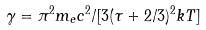Convert formula to latex. <formula><loc_0><loc_0><loc_500><loc_500>\gamma = \pi ^ { 2 } m _ { e } c ^ { 2 } / [ 3 ( \tau + 2 / 3 ) ^ { 2 } k T ]</formula> 